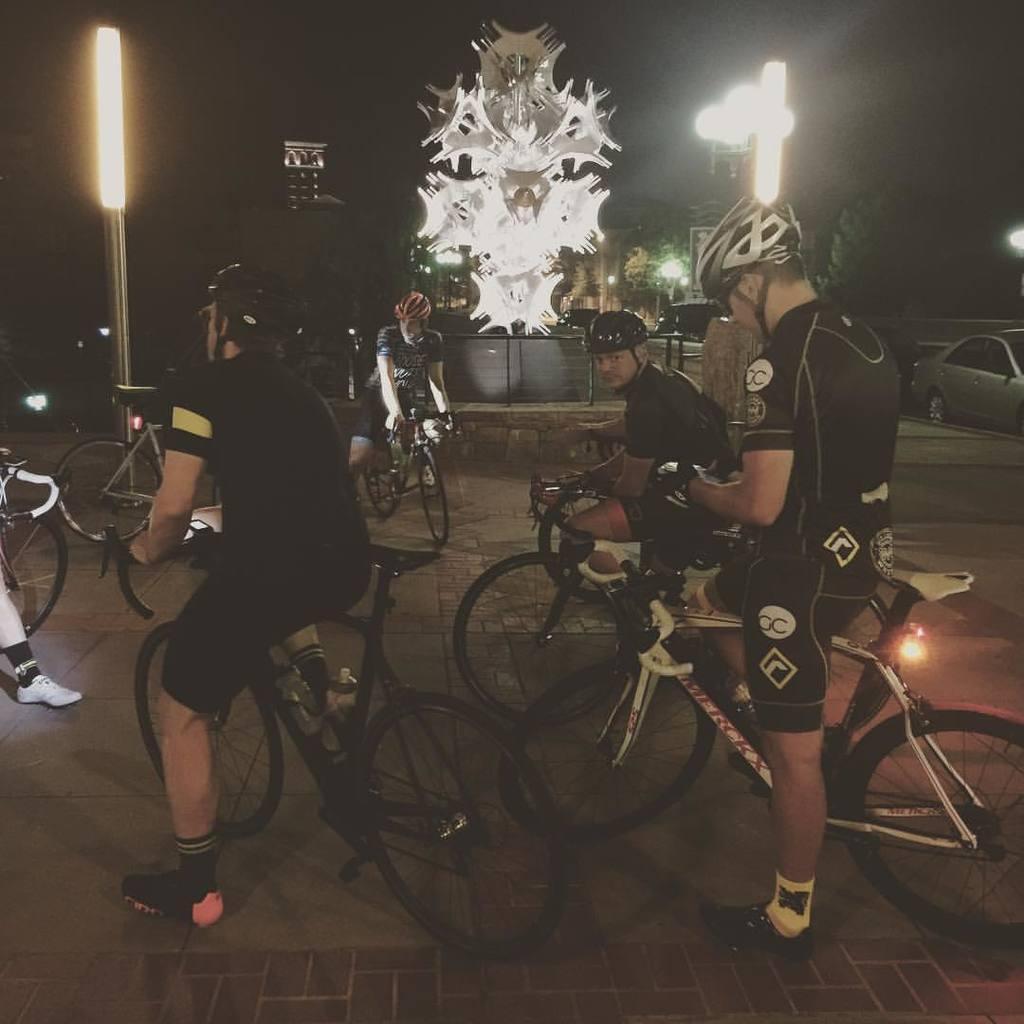Describe this image in one or two sentences. In this picture we can see few men sitting on the bicycles. There are some lights on the poles and few vehicles are visible in the background. 